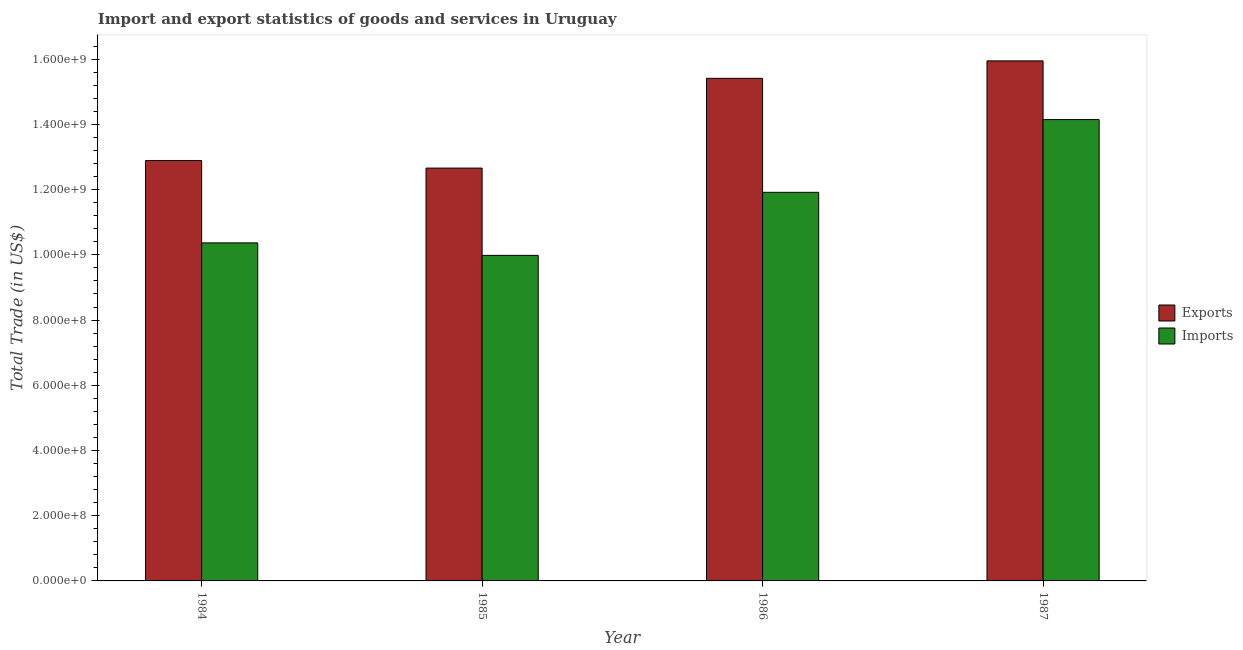How many different coloured bars are there?
Give a very brief answer. 2. How many groups of bars are there?
Provide a short and direct response. 4. Are the number of bars per tick equal to the number of legend labels?
Make the answer very short. Yes. Are the number of bars on each tick of the X-axis equal?
Keep it short and to the point. Yes. How many bars are there on the 4th tick from the right?
Offer a terse response. 2. What is the imports of goods and services in 1986?
Make the answer very short. 1.19e+09. Across all years, what is the maximum export of goods and services?
Give a very brief answer. 1.59e+09. Across all years, what is the minimum imports of goods and services?
Provide a short and direct response. 9.98e+08. In which year was the export of goods and services maximum?
Keep it short and to the point. 1987. What is the total export of goods and services in the graph?
Offer a terse response. 5.69e+09. What is the difference between the imports of goods and services in 1984 and that in 1985?
Provide a short and direct response. 3.83e+07. What is the difference between the export of goods and services in 1986 and the imports of goods and services in 1985?
Keep it short and to the point. 2.75e+08. What is the average export of goods and services per year?
Give a very brief answer. 1.42e+09. In how many years, is the export of goods and services greater than 240000000 US$?
Your answer should be very brief. 4. What is the ratio of the imports of goods and services in 1986 to that in 1987?
Your response must be concise. 0.84. Is the imports of goods and services in 1986 less than that in 1987?
Provide a succinct answer. Yes. What is the difference between the highest and the second highest imports of goods and services?
Provide a short and direct response. 2.23e+08. What is the difference between the highest and the lowest export of goods and services?
Your response must be concise. 3.29e+08. In how many years, is the export of goods and services greater than the average export of goods and services taken over all years?
Your answer should be very brief. 2. Is the sum of the imports of goods and services in 1986 and 1987 greater than the maximum export of goods and services across all years?
Your response must be concise. Yes. What does the 2nd bar from the left in 1986 represents?
Ensure brevity in your answer.  Imports. What does the 2nd bar from the right in 1984 represents?
Your answer should be very brief. Exports. How many years are there in the graph?
Offer a very short reply. 4. Are the values on the major ticks of Y-axis written in scientific E-notation?
Your answer should be compact. Yes. Where does the legend appear in the graph?
Make the answer very short. Center right. How many legend labels are there?
Your answer should be very brief. 2. What is the title of the graph?
Provide a succinct answer. Import and export statistics of goods and services in Uruguay. Does "GDP" appear as one of the legend labels in the graph?
Offer a very short reply. No. What is the label or title of the X-axis?
Offer a terse response. Year. What is the label or title of the Y-axis?
Make the answer very short. Total Trade (in US$). What is the Total Trade (in US$) in Exports in 1984?
Offer a terse response. 1.29e+09. What is the Total Trade (in US$) of Imports in 1984?
Your answer should be compact. 1.04e+09. What is the Total Trade (in US$) of Exports in 1985?
Your answer should be very brief. 1.27e+09. What is the Total Trade (in US$) in Imports in 1985?
Offer a very short reply. 9.98e+08. What is the Total Trade (in US$) in Exports in 1986?
Your response must be concise. 1.54e+09. What is the Total Trade (in US$) in Imports in 1986?
Provide a short and direct response. 1.19e+09. What is the Total Trade (in US$) of Exports in 1987?
Provide a short and direct response. 1.59e+09. What is the Total Trade (in US$) of Imports in 1987?
Give a very brief answer. 1.41e+09. Across all years, what is the maximum Total Trade (in US$) of Exports?
Keep it short and to the point. 1.59e+09. Across all years, what is the maximum Total Trade (in US$) in Imports?
Offer a very short reply. 1.41e+09. Across all years, what is the minimum Total Trade (in US$) of Exports?
Your answer should be very brief. 1.27e+09. Across all years, what is the minimum Total Trade (in US$) in Imports?
Offer a very short reply. 9.98e+08. What is the total Total Trade (in US$) of Exports in the graph?
Provide a succinct answer. 5.69e+09. What is the total Total Trade (in US$) of Imports in the graph?
Provide a short and direct response. 4.64e+09. What is the difference between the Total Trade (in US$) of Exports in 1984 and that in 1985?
Give a very brief answer. 2.31e+07. What is the difference between the Total Trade (in US$) in Imports in 1984 and that in 1985?
Your response must be concise. 3.83e+07. What is the difference between the Total Trade (in US$) of Exports in 1984 and that in 1986?
Offer a terse response. -2.52e+08. What is the difference between the Total Trade (in US$) in Imports in 1984 and that in 1986?
Offer a very short reply. -1.55e+08. What is the difference between the Total Trade (in US$) in Exports in 1984 and that in 1987?
Ensure brevity in your answer.  -3.06e+08. What is the difference between the Total Trade (in US$) of Imports in 1984 and that in 1987?
Ensure brevity in your answer.  -3.78e+08. What is the difference between the Total Trade (in US$) of Exports in 1985 and that in 1986?
Offer a very short reply. -2.75e+08. What is the difference between the Total Trade (in US$) of Imports in 1985 and that in 1986?
Offer a terse response. -1.93e+08. What is the difference between the Total Trade (in US$) in Exports in 1985 and that in 1987?
Ensure brevity in your answer.  -3.29e+08. What is the difference between the Total Trade (in US$) in Imports in 1985 and that in 1987?
Offer a very short reply. -4.17e+08. What is the difference between the Total Trade (in US$) of Exports in 1986 and that in 1987?
Your answer should be very brief. -5.35e+07. What is the difference between the Total Trade (in US$) of Imports in 1986 and that in 1987?
Your answer should be very brief. -2.23e+08. What is the difference between the Total Trade (in US$) in Exports in 1984 and the Total Trade (in US$) in Imports in 1985?
Give a very brief answer. 2.91e+08. What is the difference between the Total Trade (in US$) in Exports in 1984 and the Total Trade (in US$) in Imports in 1986?
Your answer should be compact. 9.74e+07. What is the difference between the Total Trade (in US$) in Exports in 1984 and the Total Trade (in US$) in Imports in 1987?
Your answer should be compact. -1.26e+08. What is the difference between the Total Trade (in US$) in Exports in 1985 and the Total Trade (in US$) in Imports in 1986?
Provide a succinct answer. 7.43e+07. What is the difference between the Total Trade (in US$) of Exports in 1985 and the Total Trade (in US$) of Imports in 1987?
Make the answer very short. -1.49e+08. What is the difference between the Total Trade (in US$) of Exports in 1986 and the Total Trade (in US$) of Imports in 1987?
Provide a succinct answer. 1.26e+08. What is the average Total Trade (in US$) in Exports per year?
Provide a succinct answer. 1.42e+09. What is the average Total Trade (in US$) of Imports per year?
Your answer should be compact. 1.16e+09. In the year 1984, what is the difference between the Total Trade (in US$) in Exports and Total Trade (in US$) in Imports?
Give a very brief answer. 2.52e+08. In the year 1985, what is the difference between the Total Trade (in US$) of Exports and Total Trade (in US$) of Imports?
Keep it short and to the point. 2.68e+08. In the year 1986, what is the difference between the Total Trade (in US$) in Exports and Total Trade (in US$) in Imports?
Give a very brief answer. 3.50e+08. In the year 1987, what is the difference between the Total Trade (in US$) in Exports and Total Trade (in US$) in Imports?
Offer a very short reply. 1.80e+08. What is the ratio of the Total Trade (in US$) of Exports in 1984 to that in 1985?
Provide a succinct answer. 1.02. What is the ratio of the Total Trade (in US$) in Imports in 1984 to that in 1985?
Keep it short and to the point. 1.04. What is the ratio of the Total Trade (in US$) of Exports in 1984 to that in 1986?
Give a very brief answer. 0.84. What is the ratio of the Total Trade (in US$) of Imports in 1984 to that in 1986?
Your answer should be compact. 0.87. What is the ratio of the Total Trade (in US$) of Exports in 1984 to that in 1987?
Make the answer very short. 0.81. What is the ratio of the Total Trade (in US$) in Imports in 1984 to that in 1987?
Offer a very short reply. 0.73. What is the ratio of the Total Trade (in US$) in Exports in 1985 to that in 1986?
Your answer should be compact. 0.82. What is the ratio of the Total Trade (in US$) of Imports in 1985 to that in 1986?
Your response must be concise. 0.84. What is the ratio of the Total Trade (in US$) in Exports in 1985 to that in 1987?
Give a very brief answer. 0.79. What is the ratio of the Total Trade (in US$) of Imports in 1985 to that in 1987?
Give a very brief answer. 0.71. What is the ratio of the Total Trade (in US$) in Exports in 1986 to that in 1987?
Offer a terse response. 0.97. What is the ratio of the Total Trade (in US$) of Imports in 1986 to that in 1987?
Ensure brevity in your answer.  0.84. What is the difference between the highest and the second highest Total Trade (in US$) in Exports?
Your response must be concise. 5.35e+07. What is the difference between the highest and the second highest Total Trade (in US$) of Imports?
Offer a very short reply. 2.23e+08. What is the difference between the highest and the lowest Total Trade (in US$) of Exports?
Keep it short and to the point. 3.29e+08. What is the difference between the highest and the lowest Total Trade (in US$) in Imports?
Offer a terse response. 4.17e+08. 